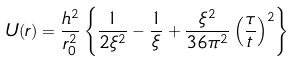Convert formula to latex. <formula><loc_0><loc_0><loc_500><loc_500>U ( r ) = \frac { h ^ { 2 } } { r _ { 0 } ^ { 2 } } \left \{ \frac { 1 } { 2 \xi ^ { 2 } } - \frac { 1 } { \xi } + \frac { \xi ^ { 2 } } { 3 6 \pi ^ { 2 } } \left ( \frac { \tau } { t } \right ) ^ { 2 } \right \}</formula> 